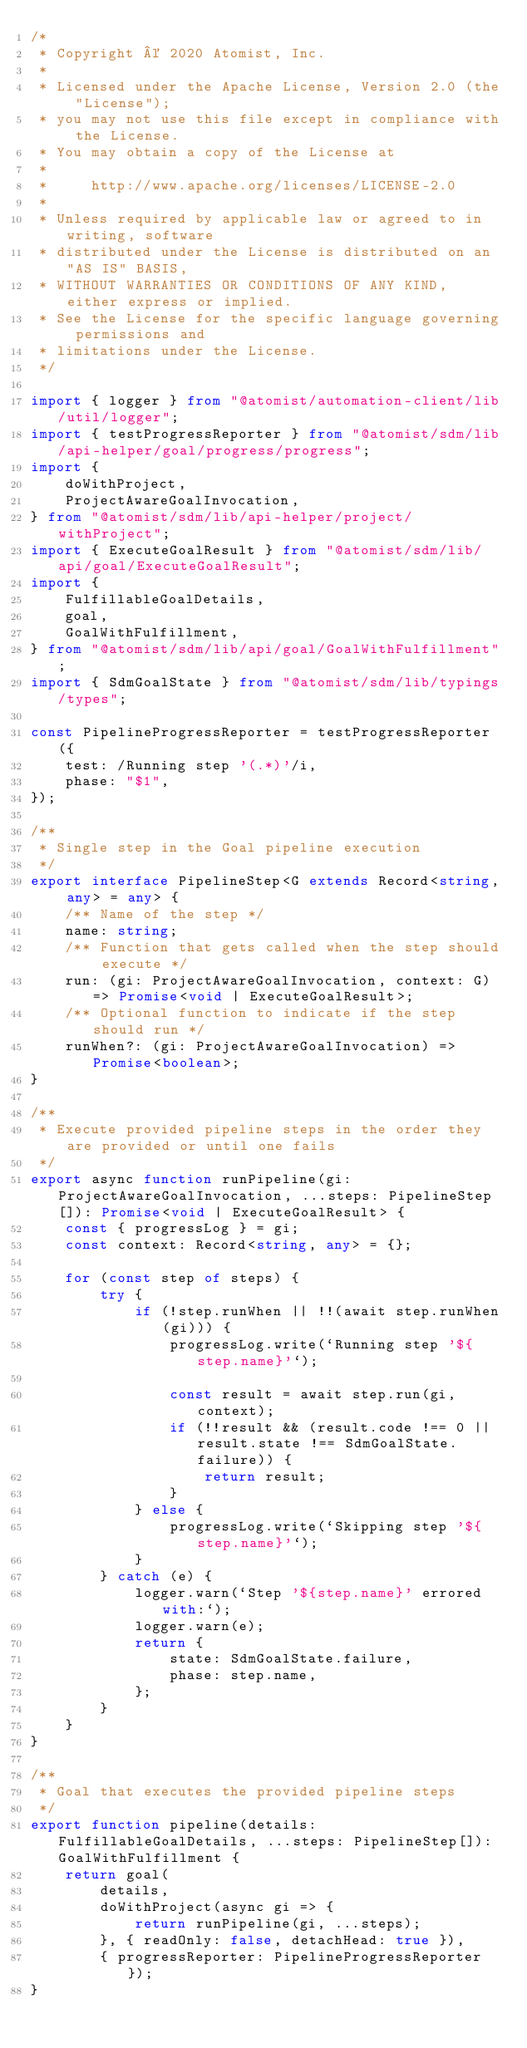Convert code to text. <code><loc_0><loc_0><loc_500><loc_500><_TypeScript_>/*
 * Copyright © 2020 Atomist, Inc.
 *
 * Licensed under the Apache License, Version 2.0 (the "License");
 * you may not use this file except in compliance with the License.
 * You may obtain a copy of the License at
 *
 *     http://www.apache.org/licenses/LICENSE-2.0
 *
 * Unless required by applicable law or agreed to in writing, software
 * distributed under the License is distributed on an "AS IS" BASIS,
 * WITHOUT WARRANTIES OR CONDITIONS OF ANY KIND, either express or implied.
 * See the License for the specific language governing permissions and
 * limitations under the License.
 */

import { logger } from "@atomist/automation-client/lib/util/logger";
import { testProgressReporter } from "@atomist/sdm/lib/api-helper/goal/progress/progress";
import {
    doWithProject,
    ProjectAwareGoalInvocation,
} from "@atomist/sdm/lib/api-helper/project/withProject";
import { ExecuteGoalResult } from "@atomist/sdm/lib/api/goal/ExecuteGoalResult";
import {
    FulfillableGoalDetails,
    goal,
    GoalWithFulfillment,
} from "@atomist/sdm/lib/api/goal/GoalWithFulfillment";
import { SdmGoalState } from "@atomist/sdm/lib/typings/types";

const PipelineProgressReporter = testProgressReporter({
    test: /Running step '(.*)'/i,
    phase: "$1",
});

/**
 * Single step in the Goal pipeline execution
 */
export interface PipelineStep<G extends Record<string, any> = any> {
    /** Name of the step */
    name: string;
    /** Function that gets called when the step should execute */
    run: (gi: ProjectAwareGoalInvocation, context: G) => Promise<void | ExecuteGoalResult>;
    /** Optional function to indicate if the step should run */
    runWhen?: (gi: ProjectAwareGoalInvocation) => Promise<boolean>;
}

/**
 * Execute provided pipeline steps in the order they are provided or until one fails
 */
export async function runPipeline(gi: ProjectAwareGoalInvocation, ...steps: PipelineStep[]): Promise<void | ExecuteGoalResult> {
    const { progressLog } = gi;
    const context: Record<string, any> = {};

    for (const step of steps) {
        try {
            if (!step.runWhen || !!(await step.runWhen(gi))) {
                progressLog.write(`Running step '${step.name}'`);

                const result = await step.run(gi, context);
                if (!!result && (result.code !== 0 || result.state !== SdmGoalState.failure)) {
                    return result;
                }
            } else {
                progressLog.write(`Skipping step '${step.name}'`);
            }
        } catch (e) {
            logger.warn(`Step '${step.name}' errored with:`);
            logger.warn(e);
            return {
                state: SdmGoalState.failure,
                phase: step.name,
            };
        }
    }
}

/**
 * Goal that executes the provided pipeline steps
 */
export function pipeline(details: FulfillableGoalDetails, ...steps: PipelineStep[]): GoalWithFulfillment {
    return goal(
        details,
        doWithProject(async gi => {
            return runPipeline(gi, ...steps);
        }, { readOnly: false, detachHead: true }),
        { progressReporter: PipelineProgressReporter });
}
</code> 